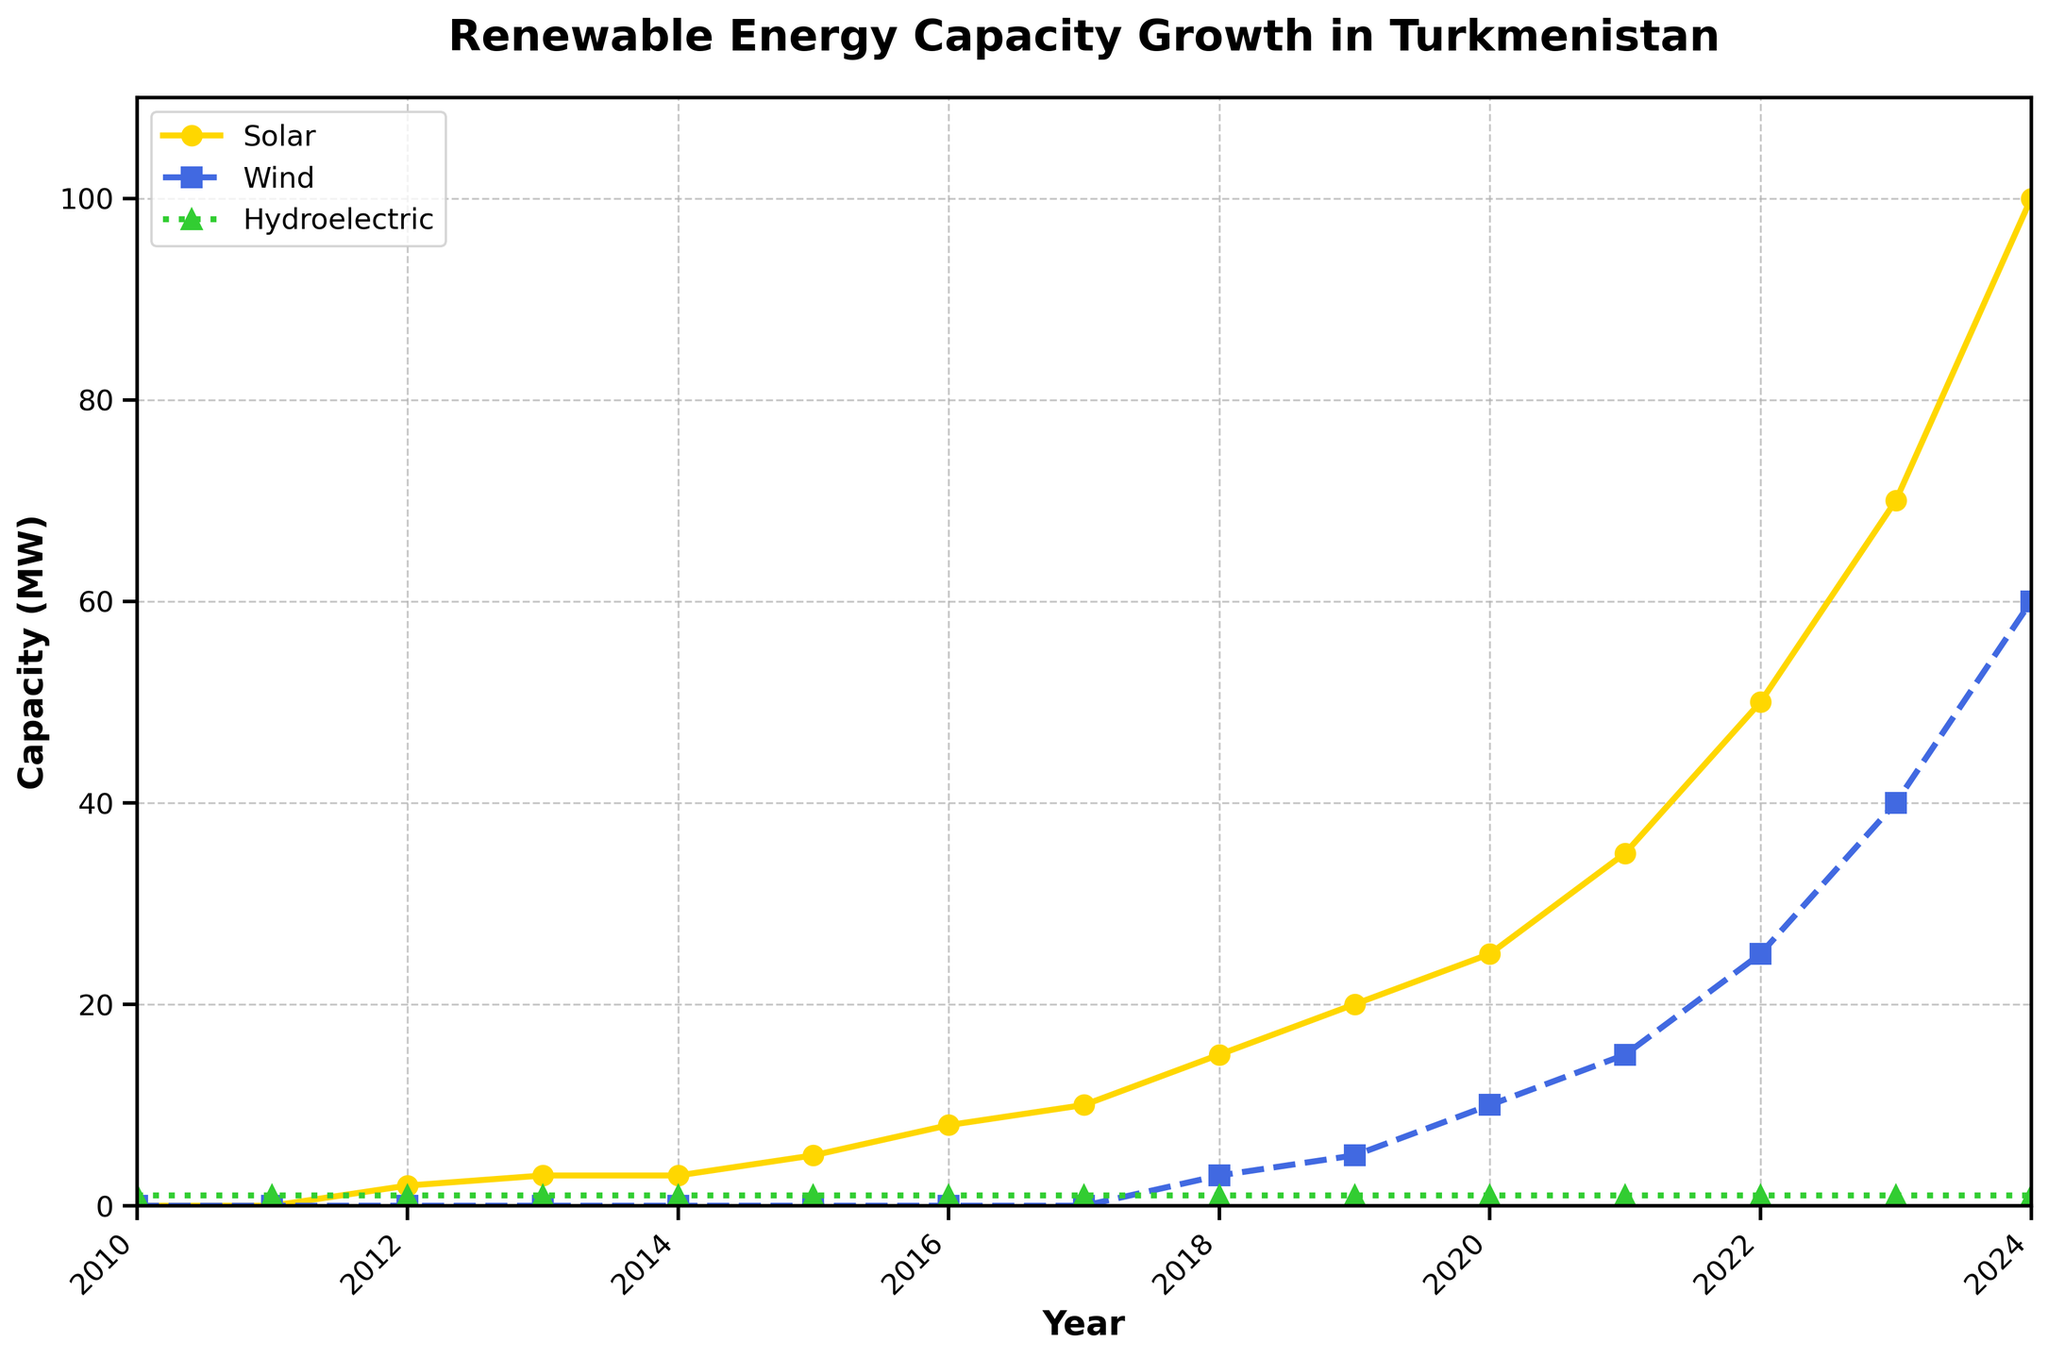What was the trend of solar energy capacity from 2010 to 2024? The plot shows an upward trend in solar energy capacity from 2010 to 2024. Starting from 0 MW in 2010, it increases significantly to 100 MW by 2024.
Answer: Upward trend Which renewable energy source had the highest capacity in 2023? In the 2023 data points, solar energy (yellow line) has the highest capacity at 70 MW, compared to wind (blue line) at 40 MW and hydroelectric (green line) at 1 MW.
Answer: Solar How much did wind energy capacity grow from 2018 to 2023? Wind energy capacity grew from 3 MW in 2018 to 40 MW in 2023. The difference is 40 - 3 = 37 MW.
Answer: 37 MW Compare the solar and wind energy capacities in 2020. Which one was greater and by how much? In 2020, solar energy had a capacity of 25 MW and wind energy had 10 MW. Solar was greater by 25 - 10 = 15 MW.
Answer: Solar by 15 MW Which energy source remained constant throughout the years depicted? The hydroelectric energy source (green line) remained constant at 1 MW from 2010 to 2024.
Answer: Hydroelectric What is the combined renewable energy capacity for the year 2022? In 2022, the capacities are: Solar = 50 MW, Wind = 25 MW, Hydroelectric = 1 MW. The total is 50 + 25 + 1 = 76 MW.
Answer: 76 MW How does the slope of the wind energy line compare to that of the solar energy line from 2019 to 2024? Both lines show an increase, but the slope of the solar energy line is steeper, indicating a faster growth rate compared to the wind energy line.
Answer: Solar has steeper slope Identify the years when solar energy capacity first surpassed wind energy capacity. Solar energy capacity first surpassed wind energy capacity in 2012 and continued to remain higher through the years.
Answer: 2012 onwards Calculate the average annual growth rate in solar energy capacity between 2010 and 2024. The solar capacity increased from 0 MW in 2010 to 100 MW in 2024. The average annual growth rate is (100 MW - 0 MW) / (2024 - 2010) = 100 / 14 ≈ 7.14 MW/year.
Answer: 7.14 MW/year 